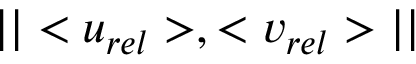Convert formula to latex. <formula><loc_0><loc_0><loc_500><loc_500>| | < u _ { r e l } > , < v _ { r e l } > | |</formula> 